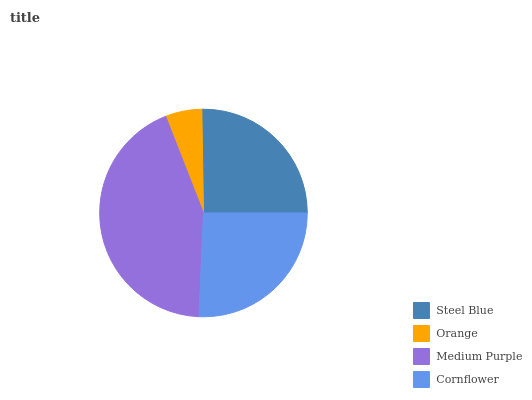Is Orange the minimum?
Answer yes or no. Yes. Is Medium Purple the maximum?
Answer yes or no. Yes. Is Medium Purple the minimum?
Answer yes or no. No. Is Orange the maximum?
Answer yes or no. No. Is Medium Purple greater than Orange?
Answer yes or no. Yes. Is Orange less than Medium Purple?
Answer yes or no. Yes. Is Orange greater than Medium Purple?
Answer yes or no. No. Is Medium Purple less than Orange?
Answer yes or no. No. Is Cornflower the high median?
Answer yes or no. Yes. Is Steel Blue the low median?
Answer yes or no. Yes. Is Medium Purple the high median?
Answer yes or no. No. Is Cornflower the low median?
Answer yes or no. No. 